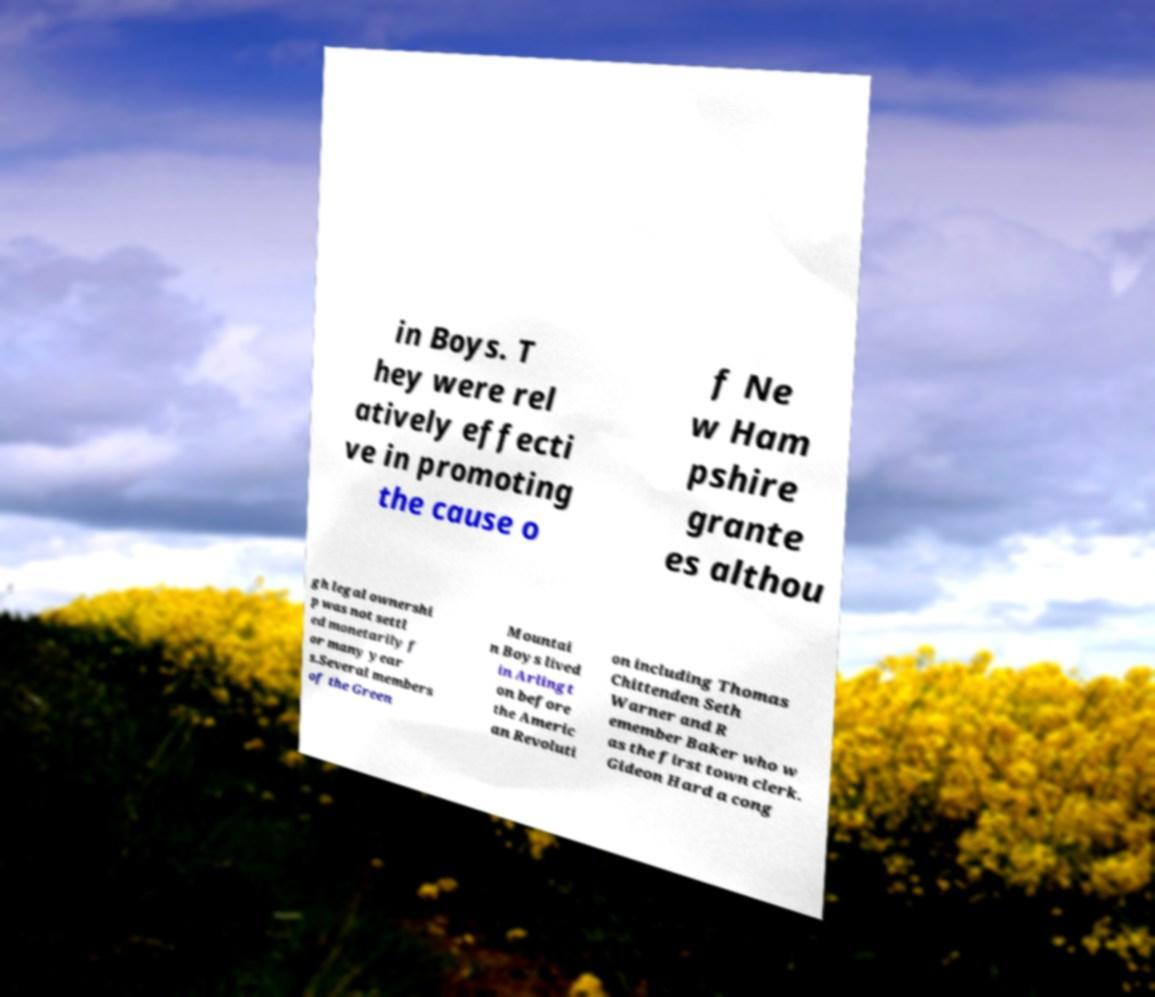Please read and relay the text visible in this image. What does it say? in Boys. T hey were rel atively effecti ve in promoting the cause o f Ne w Ham pshire grante es althou gh legal ownershi p was not settl ed monetarily f or many year s.Several members of the Green Mountai n Boys lived in Arlingt on before the Americ an Revoluti on including Thomas Chittenden Seth Warner and R emember Baker who w as the first town clerk. Gideon Hard a cong 